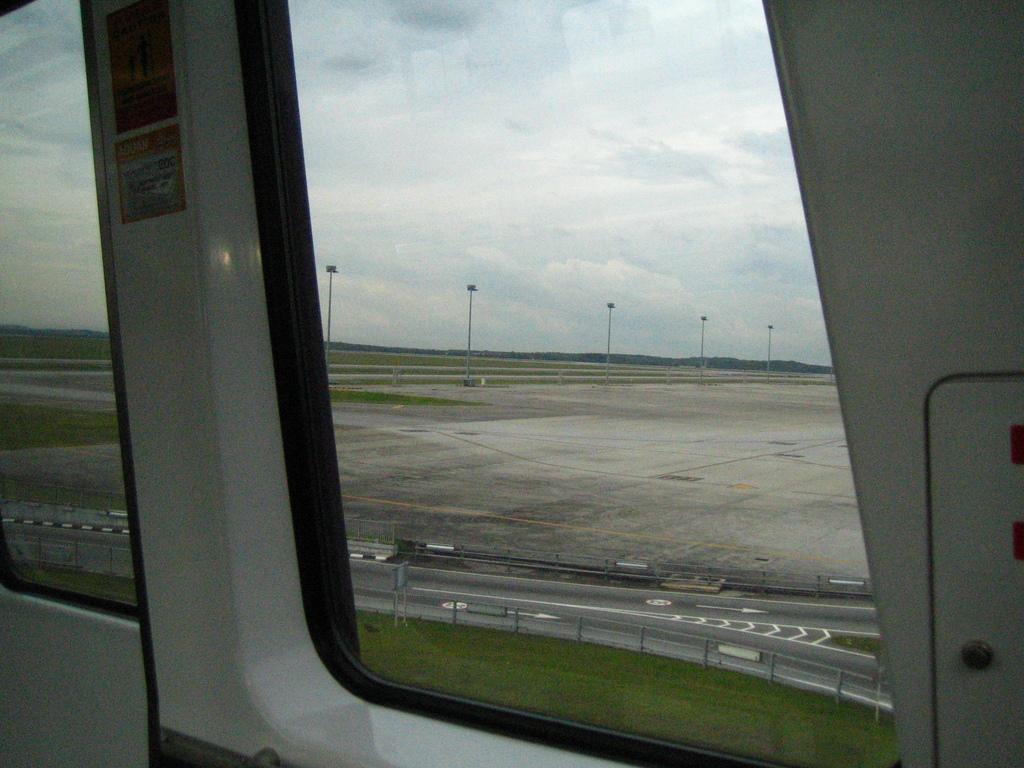What type of material is used for the windows in the image? The windows in the image are made of glass. What can be seen in the distance in the image? There is a road visible in the background of the image. What structures are present in the background of the image? There are poles in the background of the image. What is the weather like in the image? The sky is cloudy in the image. What type of square breakfast can be seen on the poles in the image? There is no square breakfast present in the image, nor are there any breakfast items on the poles. 